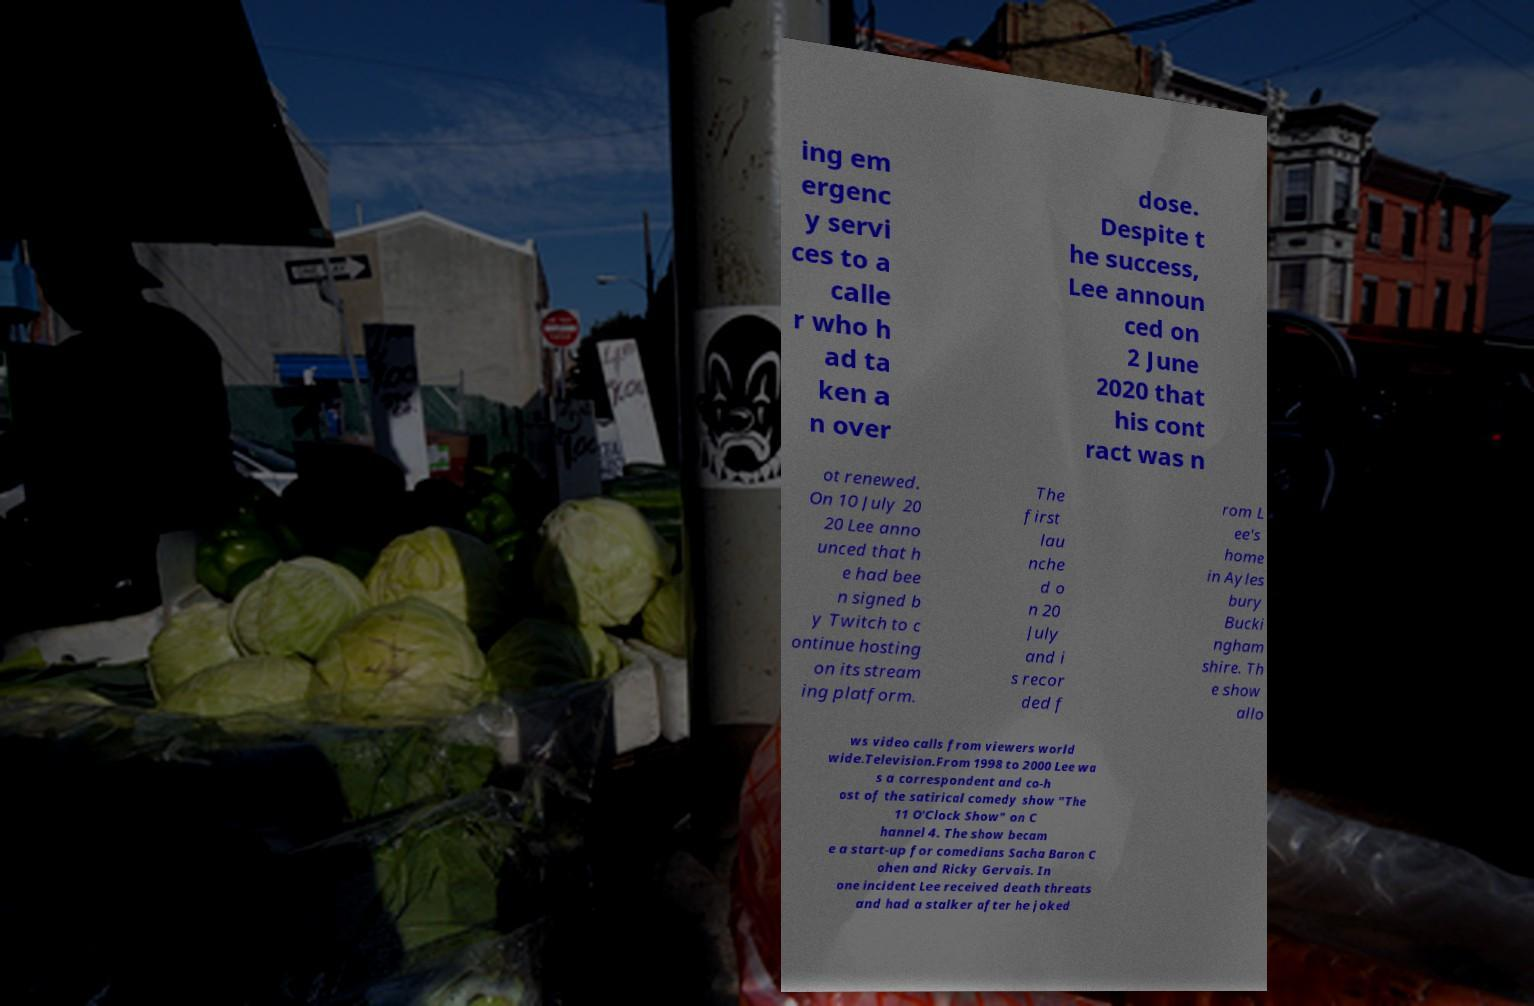Can you read and provide the text displayed in the image?This photo seems to have some interesting text. Can you extract and type it out for me? ing em ergenc y servi ces to a calle r who h ad ta ken a n over dose. Despite t he success, Lee announ ced on 2 June 2020 that his cont ract was n ot renewed. On 10 July 20 20 Lee anno unced that h e had bee n signed b y Twitch to c ontinue hosting on its stream ing platform. The first lau nche d o n 20 July and i s recor ded f rom L ee's home in Ayles bury Bucki ngham shire. Th e show allo ws video calls from viewers world wide.Television.From 1998 to 2000 Lee wa s a correspondent and co-h ost of the satirical comedy show "The 11 O'Clock Show" on C hannel 4. The show becam e a start-up for comedians Sacha Baron C ohen and Ricky Gervais. In one incident Lee received death threats and had a stalker after he joked 